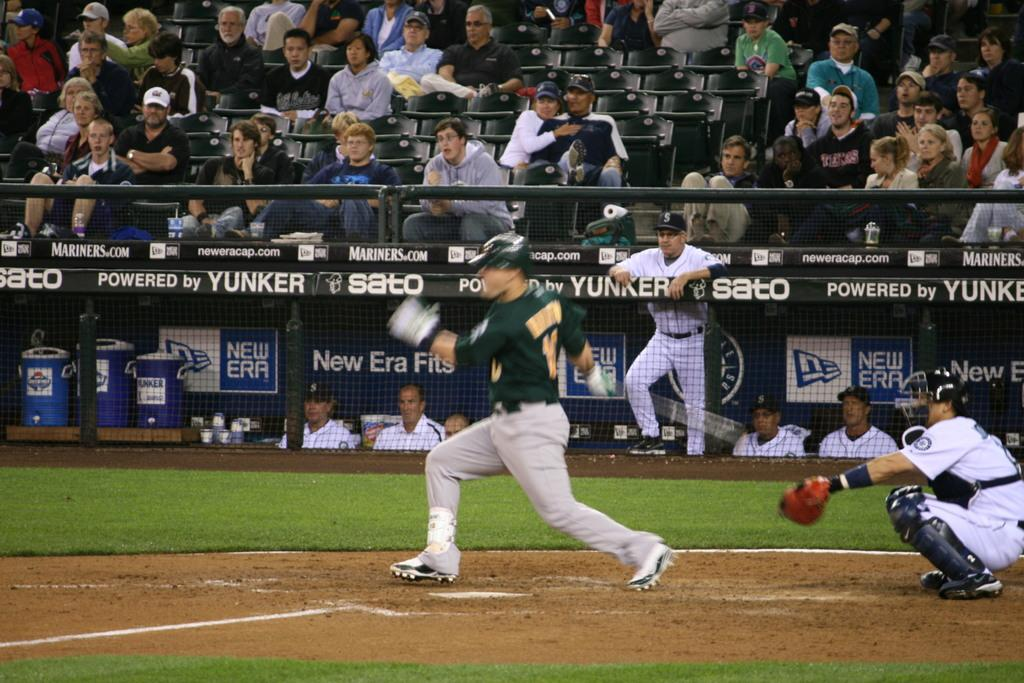Provide a one-sentence caption for the provided image. A baseball player takes a swing with New Era ads in the background. 